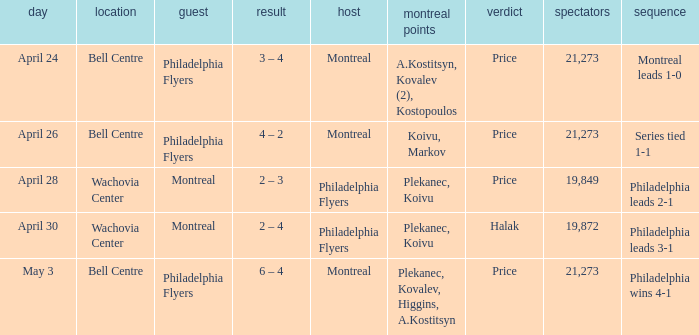What was the average attendance when the decision was price and montreal were the visitors? 19849.0. 